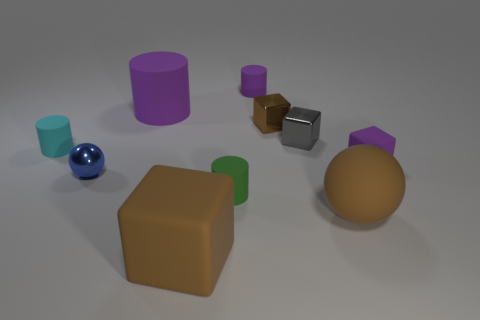What shape is the small rubber object that is the same color as the small rubber block?
Make the answer very short. Cylinder. Are there more large rubber objects to the left of the metallic sphere than gray cylinders?
Your answer should be compact. No. What material is the big thing that is in front of the small gray thing and left of the green matte cylinder?
Ensure brevity in your answer.  Rubber. Is there any other thing that has the same shape as the small blue thing?
Keep it short and to the point. Yes. What number of objects are to the right of the brown metal object and in front of the tiny sphere?
Make the answer very short. 1. What material is the blue ball?
Ensure brevity in your answer.  Metal. Are there the same number of large blocks in front of the gray metal cube and gray spheres?
Offer a very short reply. No. What number of big matte things are the same shape as the blue shiny object?
Your response must be concise. 1. Is the blue shiny thing the same shape as the cyan matte thing?
Keep it short and to the point. No. What number of things are either big matte objects that are behind the small ball or gray metal objects?
Keep it short and to the point. 2. 